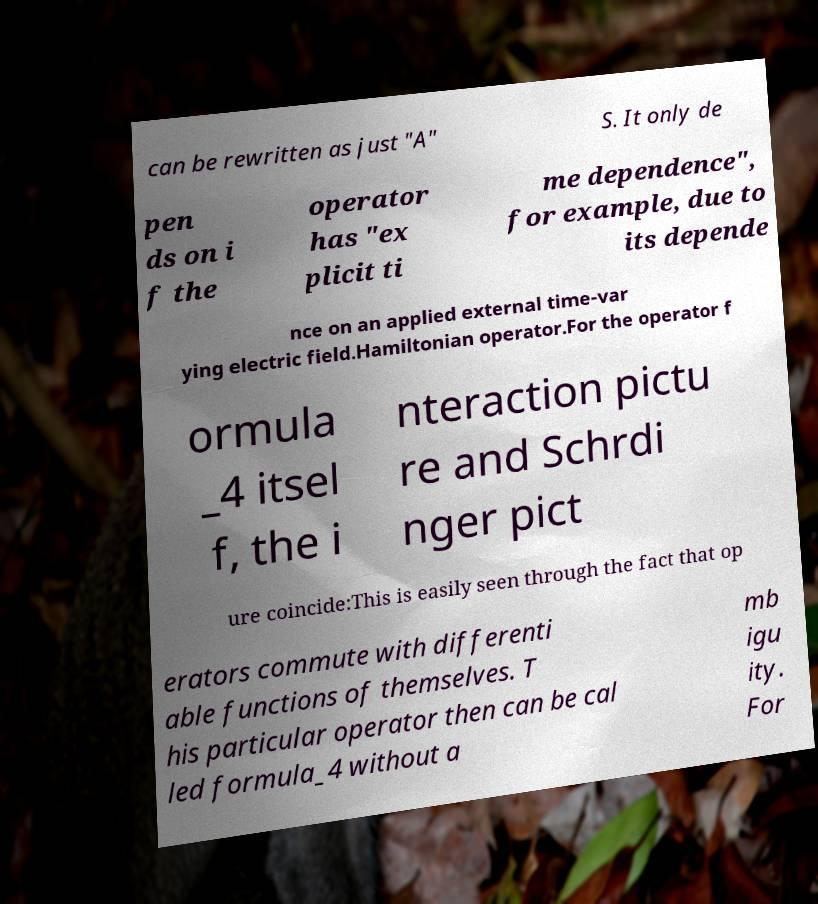Can you accurately transcribe the text from the provided image for me? can be rewritten as just "A" S. It only de pen ds on i f the operator has "ex plicit ti me dependence", for example, due to its depende nce on an applied external time-var ying electric field.Hamiltonian operator.For the operator f ormula _4 itsel f, the i nteraction pictu re and Schrdi nger pict ure coincide:This is easily seen through the fact that op erators commute with differenti able functions of themselves. T his particular operator then can be cal led formula_4 without a mb igu ity. For 